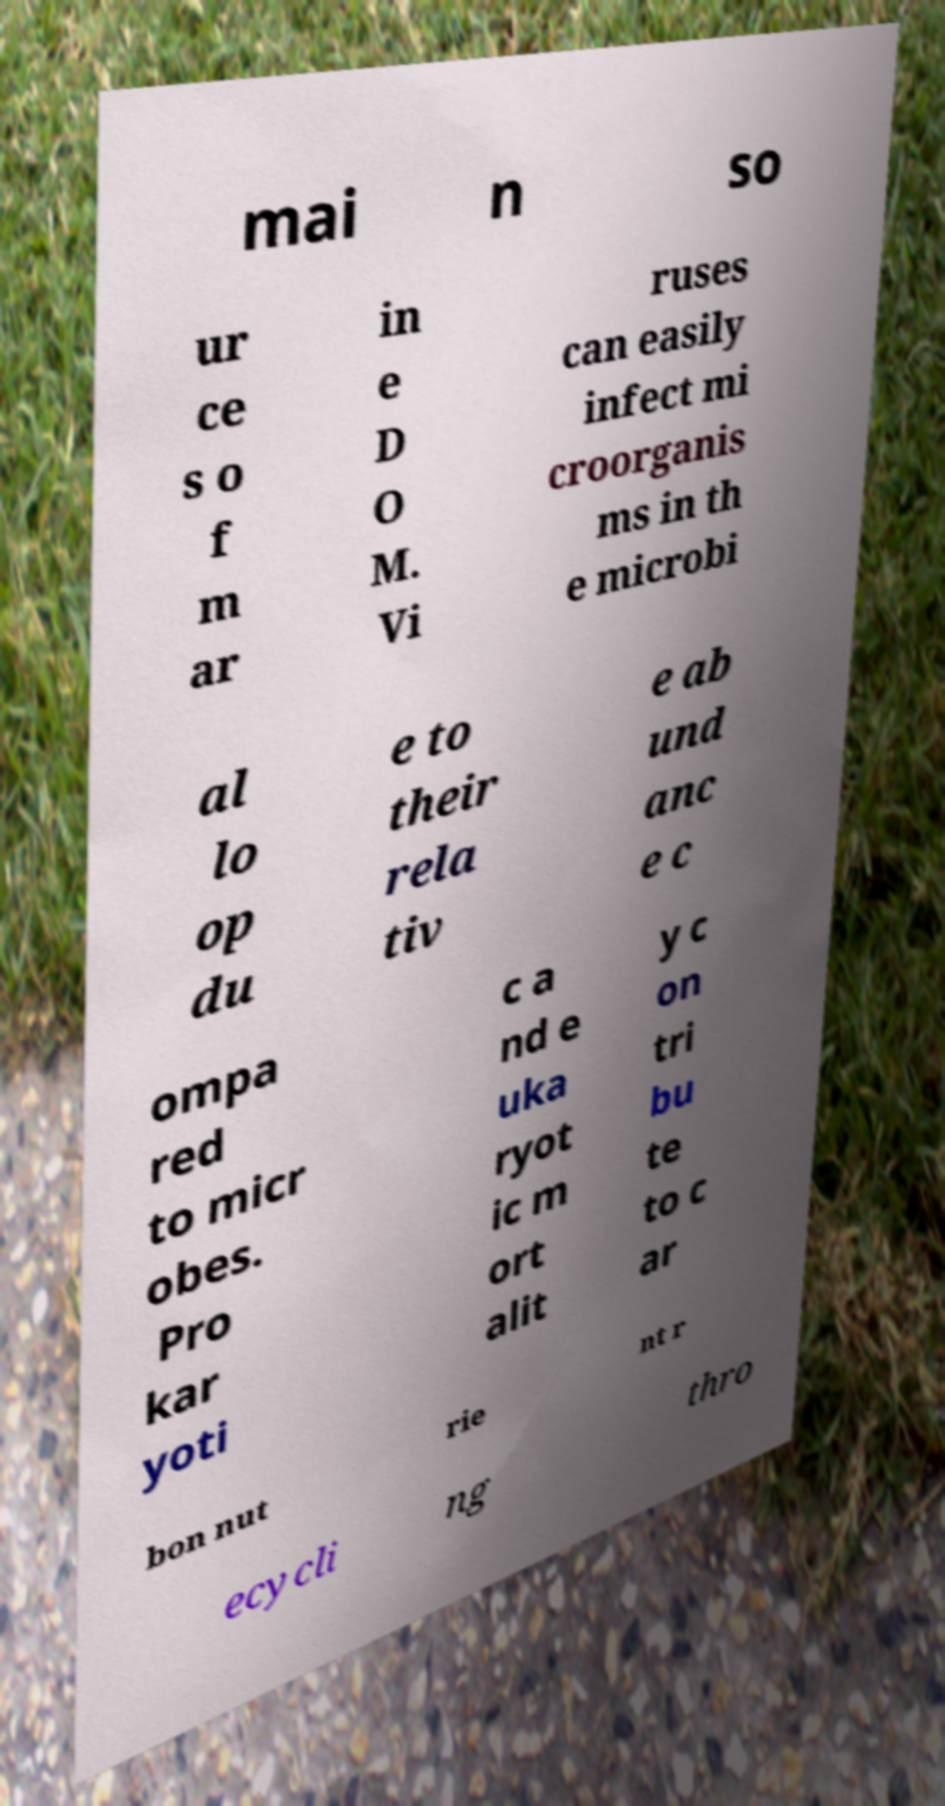Could you assist in decoding the text presented in this image and type it out clearly? mai n so ur ce s o f m ar in e D O M. Vi ruses can easily infect mi croorganis ms in th e microbi al lo op du e to their rela tiv e ab und anc e c ompa red to micr obes. Pro kar yoti c a nd e uka ryot ic m ort alit y c on tri bu te to c ar bon nut rie nt r ecycli ng thro 